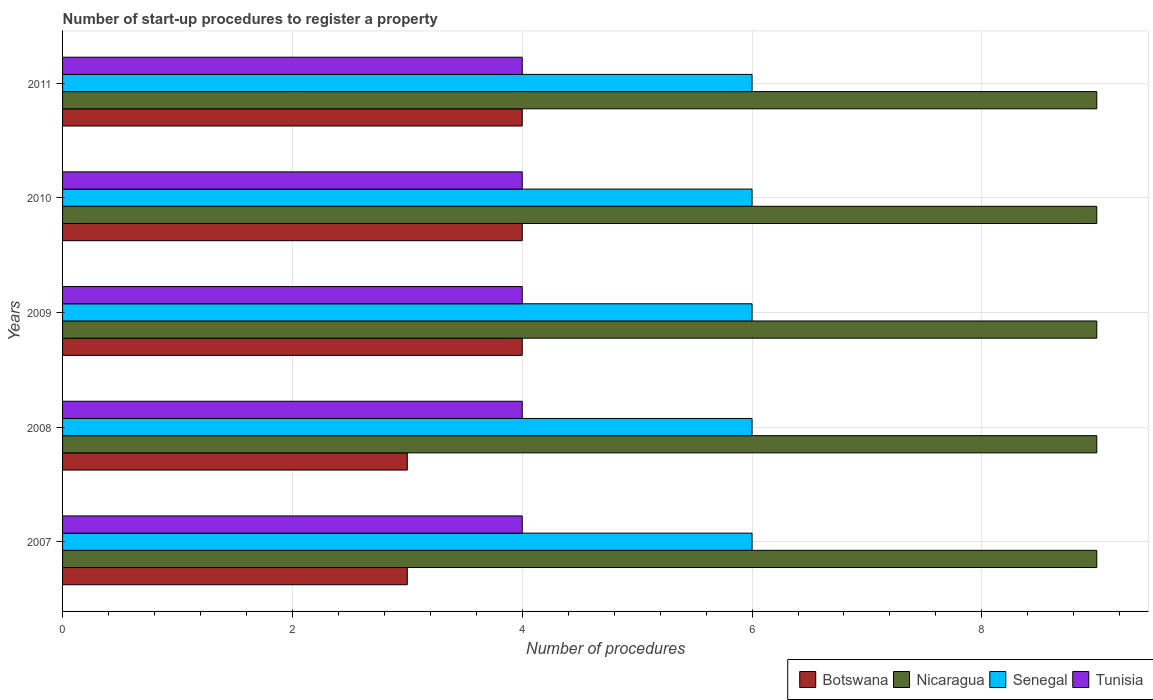How many different coloured bars are there?
Provide a succinct answer. 4. Are the number of bars per tick equal to the number of legend labels?
Offer a very short reply. Yes. Are the number of bars on each tick of the Y-axis equal?
Provide a succinct answer. Yes. What is the label of the 1st group of bars from the top?
Your response must be concise. 2011. What is the number of procedures required to register a property in Botswana in 2008?
Ensure brevity in your answer.  3. Across all years, what is the maximum number of procedures required to register a property in Botswana?
Provide a short and direct response. 4. Across all years, what is the minimum number of procedures required to register a property in Tunisia?
Your response must be concise. 4. In which year was the number of procedures required to register a property in Botswana minimum?
Provide a short and direct response. 2007. What is the total number of procedures required to register a property in Tunisia in the graph?
Offer a very short reply. 20. What is the difference between the number of procedures required to register a property in Nicaragua in 2010 and that in 2011?
Give a very brief answer. 0. What is the difference between the number of procedures required to register a property in Nicaragua in 2010 and the number of procedures required to register a property in Botswana in 2009?
Provide a short and direct response. 5. In the year 2007, what is the difference between the number of procedures required to register a property in Senegal and number of procedures required to register a property in Nicaragua?
Keep it short and to the point. -3. Is the number of procedures required to register a property in Nicaragua in 2008 less than that in 2009?
Give a very brief answer. No. Is the difference between the number of procedures required to register a property in Senegal in 2007 and 2010 greater than the difference between the number of procedures required to register a property in Nicaragua in 2007 and 2010?
Offer a terse response. No. What does the 2nd bar from the top in 2010 represents?
Keep it short and to the point. Senegal. What does the 3rd bar from the bottom in 2011 represents?
Your answer should be very brief. Senegal. How many bars are there?
Keep it short and to the point. 20. How many years are there in the graph?
Keep it short and to the point. 5. What is the difference between two consecutive major ticks on the X-axis?
Your answer should be very brief. 2. Are the values on the major ticks of X-axis written in scientific E-notation?
Your response must be concise. No. Where does the legend appear in the graph?
Provide a short and direct response. Bottom right. What is the title of the graph?
Offer a very short reply. Number of start-up procedures to register a property. What is the label or title of the X-axis?
Offer a very short reply. Number of procedures. What is the Number of procedures of Nicaragua in 2007?
Offer a terse response. 9. What is the Number of procedures in Botswana in 2009?
Provide a succinct answer. 4. What is the Number of procedures in Nicaragua in 2009?
Provide a short and direct response. 9. What is the Number of procedures in Senegal in 2009?
Offer a very short reply. 6. What is the Number of procedures of Tunisia in 2009?
Your response must be concise. 4. What is the Number of procedures of Botswana in 2010?
Give a very brief answer. 4. What is the Number of procedures of Tunisia in 2010?
Give a very brief answer. 4. What is the Number of procedures of Botswana in 2011?
Make the answer very short. 4. What is the Number of procedures in Nicaragua in 2011?
Give a very brief answer. 9. What is the Number of procedures of Senegal in 2011?
Give a very brief answer. 6. Across all years, what is the maximum Number of procedures in Botswana?
Ensure brevity in your answer.  4. Across all years, what is the maximum Number of procedures in Nicaragua?
Your answer should be compact. 9. Across all years, what is the maximum Number of procedures of Senegal?
Offer a very short reply. 6. Across all years, what is the minimum Number of procedures in Botswana?
Make the answer very short. 3. Across all years, what is the minimum Number of procedures in Senegal?
Keep it short and to the point. 6. What is the total Number of procedures in Nicaragua in the graph?
Offer a very short reply. 45. What is the difference between the Number of procedures in Nicaragua in 2007 and that in 2008?
Ensure brevity in your answer.  0. What is the difference between the Number of procedures of Botswana in 2007 and that in 2009?
Provide a short and direct response. -1. What is the difference between the Number of procedures of Nicaragua in 2007 and that in 2009?
Offer a terse response. 0. What is the difference between the Number of procedures in Senegal in 2007 and that in 2009?
Provide a short and direct response. 0. What is the difference between the Number of procedures of Nicaragua in 2007 and that in 2010?
Provide a succinct answer. 0. What is the difference between the Number of procedures in Senegal in 2007 and that in 2010?
Provide a short and direct response. 0. What is the difference between the Number of procedures of Tunisia in 2007 and that in 2010?
Keep it short and to the point. 0. What is the difference between the Number of procedures of Botswana in 2007 and that in 2011?
Offer a very short reply. -1. What is the difference between the Number of procedures of Nicaragua in 2007 and that in 2011?
Offer a terse response. 0. What is the difference between the Number of procedures in Nicaragua in 2008 and that in 2010?
Ensure brevity in your answer.  0. What is the difference between the Number of procedures in Senegal in 2008 and that in 2010?
Offer a very short reply. 0. What is the difference between the Number of procedures of Tunisia in 2008 and that in 2010?
Your response must be concise. 0. What is the difference between the Number of procedures of Botswana in 2008 and that in 2011?
Offer a very short reply. -1. What is the difference between the Number of procedures of Nicaragua in 2008 and that in 2011?
Ensure brevity in your answer.  0. What is the difference between the Number of procedures of Senegal in 2008 and that in 2011?
Provide a short and direct response. 0. What is the difference between the Number of procedures in Tunisia in 2008 and that in 2011?
Provide a succinct answer. 0. What is the difference between the Number of procedures in Botswana in 2009 and that in 2010?
Keep it short and to the point. 0. What is the difference between the Number of procedures in Tunisia in 2009 and that in 2010?
Provide a short and direct response. 0. What is the difference between the Number of procedures of Botswana in 2009 and that in 2011?
Your answer should be very brief. 0. What is the difference between the Number of procedures in Senegal in 2009 and that in 2011?
Give a very brief answer. 0. What is the difference between the Number of procedures in Tunisia in 2009 and that in 2011?
Provide a succinct answer. 0. What is the difference between the Number of procedures of Botswana in 2007 and the Number of procedures of Senegal in 2008?
Offer a terse response. -3. What is the difference between the Number of procedures in Nicaragua in 2007 and the Number of procedures in Senegal in 2008?
Provide a succinct answer. 3. What is the difference between the Number of procedures in Nicaragua in 2007 and the Number of procedures in Tunisia in 2008?
Provide a succinct answer. 5. What is the difference between the Number of procedures of Botswana in 2007 and the Number of procedures of Nicaragua in 2009?
Provide a succinct answer. -6. What is the difference between the Number of procedures in Botswana in 2007 and the Number of procedures in Senegal in 2009?
Your response must be concise. -3. What is the difference between the Number of procedures of Nicaragua in 2007 and the Number of procedures of Senegal in 2009?
Provide a short and direct response. 3. What is the difference between the Number of procedures in Nicaragua in 2007 and the Number of procedures in Tunisia in 2009?
Your answer should be compact. 5. What is the difference between the Number of procedures of Senegal in 2007 and the Number of procedures of Tunisia in 2009?
Provide a short and direct response. 2. What is the difference between the Number of procedures of Nicaragua in 2007 and the Number of procedures of Senegal in 2010?
Make the answer very short. 3. What is the difference between the Number of procedures in Nicaragua in 2007 and the Number of procedures in Tunisia in 2010?
Offer a terse response. 5. What is the difference between the Number of procedures of Senegal in 2007 and the Number of procedures of Tunisia in 2010?
Your answer should be compact. 2. What is the difference between the Number of procedures in Nicaragua in 2007 and the Number of procedures in Senegal in 2011?
Your response must be concise. 3. What is the difference between the Number of procedures of Nicaragua in 2007 and the Number of procedures of Tunisia in 2011?
Provide a succinct answer. 5. What is the difference between the Number of procedures of Senegal in 2007 and the Number of procedures of Tunisia in 2011?
Ensure brevity in your answer.  2. What is the difference between the Number of procedures of Botswana in 2008 and the Number of procedures of Senegal in 2009?
Your response must be concise. -3. What is the difference between the Number of procedures in Nicaragua in 2008 and the Number of procedures in Tunisia in 2009?
Your answer should be very brief. 5. What is the difference between the Number of procedures of Senegal in 2008 and the Number of procedures of Tunisia in 2009?
Provide a succinct answer. 2. What is the difference between the Number of procedures of Botswana in 2008 and the Number of procedures of Nicaragua in 2010?
Your answer should be very brief. -6. What is the difference between the Number of procedures of Botswana in 2008 and the Number of procedures of Tunisia in 2010?
Your answer should be compact. -1. What is the difference between the Number of procedures of Nicaragua in 2008 and the Number of procedures of Senegal in 2010?
Your answer should be compact. 3. What is the difference between the Number of procedures of Senegal in 2008 and the Number of procedures of Tunisia in 2010?
Keep it short and to the point. 2. What is the difference between the Number of procedures of Botswana in 2008 and the Number of procedures of Nicaragua in 2011?
Your answer should be compact. -6. What is the difference between the Number of procedures in Botswana in 2008 and the Number of procedures in Senegal in 2011?
Make the answer very short. -3. What is the difference between the Number of procedures in Nicaragua in 2008 and the Number of procedures in Senegal in 2011?
Offer a very short reply. 3. What is the difference between the Number of procedures of Botswana in 2009 and the Number of procedures of Senegal in 2010?
Provide a succinct answer. -2. What is the difference between the Number of procedures of Nicaragua in 2009 and the Number of procedures of Senegal in 2010?
Ensure brevity in your answer.  3. What is the difference between the Number of procedures in Nicaragua in 2009 and the Number of procedures in Tunisia in 2010?
Provide a short and direct response. 5. What is the average Number of procedures of Nicaragua per year?
Your answer should be very brief. 9. In the year 2007, what is the difference between the Number of procedures of Botswana and Number of procedures of Nicaragua?
Keep it short and to the point. -6. In the year 2007, what is the difference between the Number of procedures in Senegal and Number of procedures in Tunisia?
Make the answer very short. 2. In the year 2008, what is the difference between the Number of procedures in Botswana and Number of procedures in Tunisia?
Offer a terse response. -1. In the year 2008, what is the difference between the Number of procedures of Nicaragua and Number of procedures of Senegal?
Keep it short and to the point. 3. In the year 2008, what is the difference between the Number of procedures in Nicaragua and Number of procedures in Tunisia?
Keep it short and to the point. 5. In the year 2009, what is the difference between the Number of procedures of Botswana and Number of procedures of Nicaragua?
Ensure brevity in your answer.  -5. In the year 2009, what is the difference between the Number of procedures in Botswana and Number of procedures in Senegal?
Provide a short and direct response. -2. In the year 2010, what is the difference between the Number of procedures in Botswana and Number of procedures in Senegal?
Offer a terse response. -2. In the year 2010, what is the difference between the Number of procedures of Nicaragua and Number of procedures of Tunisia?
Your answer should be very brief. 5. In the year 2010, what is the difference between the Number of procedures in Senegal and Number of procedures in Tunisia?
Make the answer very short. 2. In the year 2011, what is the difference between the Number of procedures in Botswana and Number of procedures in Nicaragua?
Offer a very short reply. -5. In the year 2011, what is the difference between the Number of procedures in Botswana and Number of procedures in Senegal?
Your answer should be very brief. -2. In the year 2011, what is the difference between the Number of procedures of Botswana and Number of procedures of Tunisia?
Ensure brevity in your answer.  0. In the year 2011, what is the difference between the Number of procedures in Senegal and Number of procedures in Tunisia?
Your answer should be very brief. 2. What is the ratio of the Number of procedures of Botswana in 2007 to that in 2008?
Ensure brevity in your answer.  1. What is the ratio of the Number of procedures in Nicaragua in 2007 to that in 2008?
Your answer should be very brief. 1. What is the ratio of the Number of procedures of Senegal in 2007 to that in 2008?
Your answer should be very brief. 1. What is the ratio of the Number of procedures in Tunisia in 2007 to that in 2008?
Offer a very short reply. 1. What is the ratio of the Number of procedures in Nicaragua in 2007 to that in 2009?
Provide a short and direct response. 1. What is the ratio of the Number of procedures of Tunisia in 2007 to that in 2009?
Your response must be concise. 1. What is the ratio of the Number of procedures of Botswana in 2007 to that in 2010?
Your answer should be compact. 0.75. What is the ratio of the Number of procedures of Nicaragua in 2007 to that in 2011?
Keep it short and to the point. 1. What is the ratio of the Number of procedures in Senegal in 2007 to that in 2011?
Ensure brevity in your answer.  1. What is the ratio of the Number of procedures of Botswana in 2008 to that in 2009?
Ensure brevity in your answer.  0.75. What is the ratio of the Number of procedures of Botswana in 2008 to that in 2010?
Your response must be concise. 0.75. What is the ratio of the Number of procedures in Nicaragua in 2008 to that in 2010?
Ensure brevity in your answer.  1. What is the ratio of the Number of procedures in Botswana in 2008 to that in 2011?
Ensure brevity in your answer.  0.75. What is the ratio of the Number of procedures in Senegal in 2008 to that in 2011?
Offer a terse response. 1. What is the ratio of the Number of procedures in Tunisia in 2008 to that in 2011?
Keep it short and to the point. 1. What is the ratio of the Number of procedures in Botswana in 2009 to that in 2010?
Your response must be concise. 1. What is the ratio of the Number of procedures of Nicaragua in 2009 to that in 2010?
Keep it short and to the point. 1. What is the ratio of the Number of procedures of Tunisia in 2009 to that in 2010?
Your answer should be very brief. 1. What is the ratio of the Number of procedures in Botswana in 2009 to that in 2011?
Offer a very short reply. 1. What is the ratio of the Number of procedures in Nicaragua in 2009 to that in 2011?
Ensure brevity in your answer.  1. What is the ratio of the Number of procedures in Senegal in 2009 to that in 2011?
Offer a very short reply. 1. What is the ratio of the Number of procedures in Tunisia in 2009 to that in 2011?
Give a very brief answer. 1. What is the ratio of the Number of procedures in Botswana in 2010 to that in 2011?
Provide a succinct answer. 1. What is the ratio of the Number of procedures of Senegal in 2010 to that in 2011?
Offer a terse response. 1. What is the ratio of the Number of procedures in Tunisia in 2010 to that in 2011?
Your response must be concise. 1. What is the difference between the highest and the second highest Number of procedures in Botswana?
Offer a very short reply. 0. What is the difference between the highest and the lowest Number of procedures in Botswana?
Ensure brevity in your answer.  1. What is the difference between the highest and the lowest Number of procedures of Nicaragua?
Your answer should be compact. 0. What is the difference between the highest and the lowest Number of procedures in Tunisia?
Give a very brief answer. 0. 